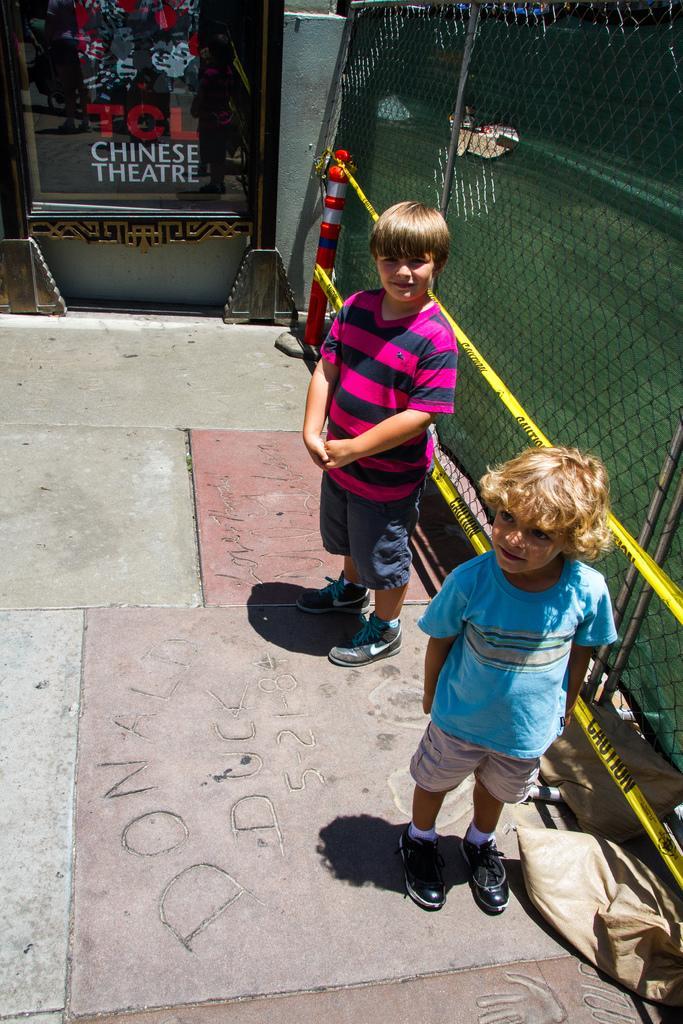Could you give a brief overview of what you see in this image? In this image in the center there are kids standing and smiling. On the right side there is a fence. In the center there is a banner with some text written on it which is black in colour and there is a wall. 